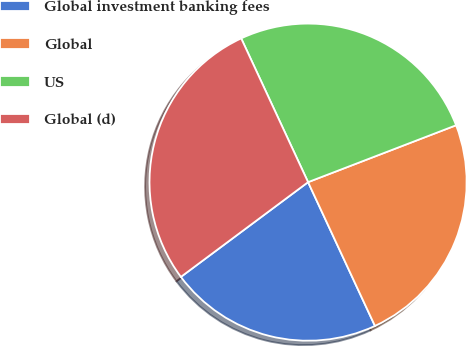Convert chart. <chart><loc_0><loc_0><loc_500><loc_500><pie_chart><fcel>Global investment banking fees<fcel>Global<fcel>US<fcel>Global (d)<nl><fcel>21.74%<fcel>23.91%<fcel>26.09%<fcel>28.26%<nl></chart> 